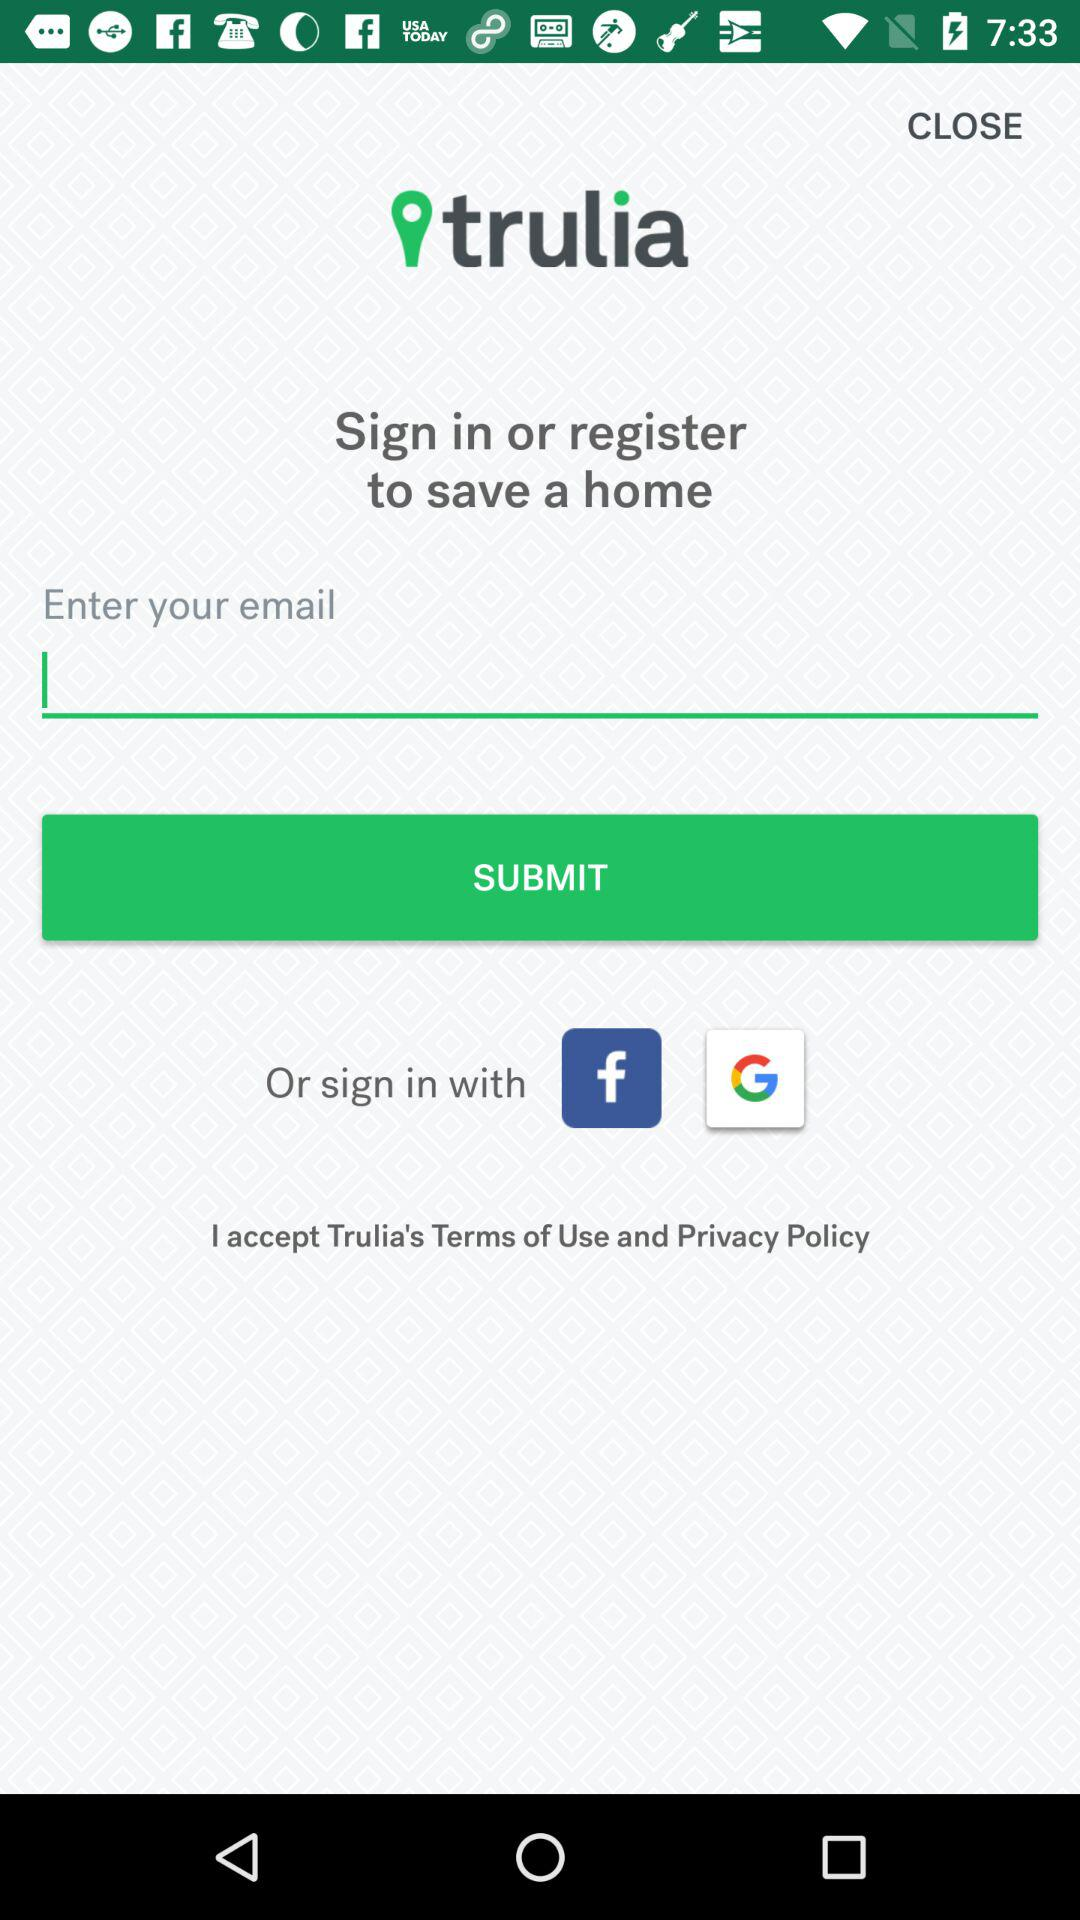Which app can we use to sign in? You can sign in with "Facebook" and "Google". 